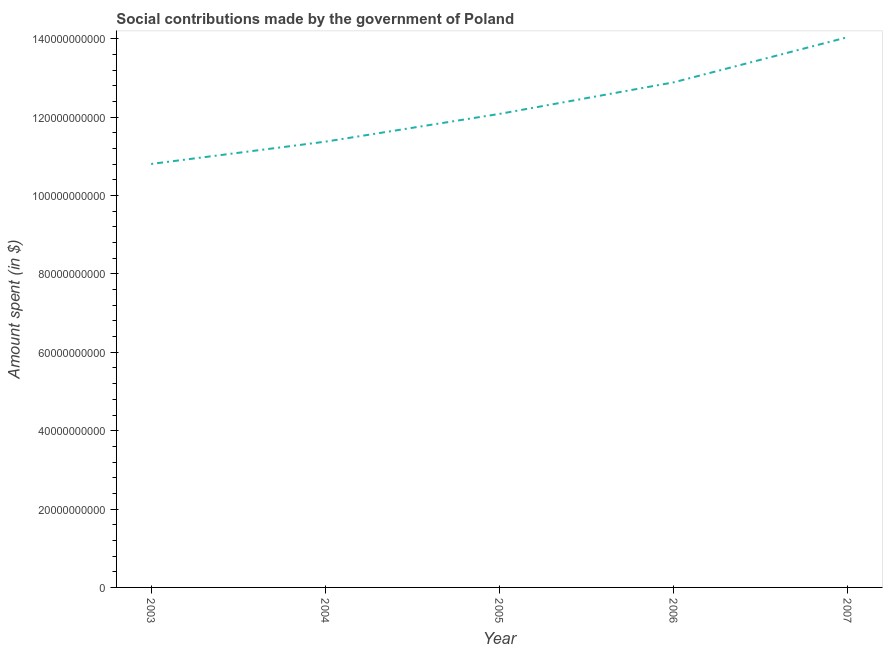What is the amount spent in making social contributions in 2003?
Your answer should be compact. 1.08e+11. Across all years, what is the maximum amount spent in making social contributions?
Give a very brief answer. 1.40e+11. Across all years, what is the minimum amount spent in making social contributions?
Offer a terse response. 1.08e+11. In which year was the amount spent in making social contributions minimum?
Ensure brevity in your answer.  2003. What is the sum of the amount spent in making social contributions?
Your response must be concise. 6.12e+11. What is the difference between the amount spent in making social contributions in 2005 and 2007?
Provide a short and direct response. -1.96e+1. What is the average amount spent in making social contributions per year?
Give a very brief answer. 1.22e+11. What is the median amount spent in making social contributions?
Provide a short and direct response. 1.21e+11. What is the ratio of the amount spent in making social contributions in 2004 to that in 2006?
Your answer should be compact. 0.88. Is the difference between the amount spent in making social contributions in 2005 and 2007 greater than the difference between any two years?
Your answer should be compact. No. What is the difference between the highest and the second highest amount spent in making social contributions?
Keep it short and to the point. 1.15e+1. Is the sum of the amount spent in making social contributions in 2005 and 2007 greater than the maximum amount spent in making social contributions across all years?
Your answer should be very brief. Yes. What is the difference between the highest and the lowest amount spent in making social contributions?
Keep it short and to the point. 3.24e+1. How many lines are there?
Provide a short and direct response. 1. How many years are there in the graph?
Your response must be concise. 5. Are the values on the major ticks of Y-axis written in scientific E-notation?
Make the answer very short. No. Does the graph contain any zero values?
Offer a terse response. No. Does the graph contain grids?
Make the answer very short. No. What is the title of the graph?
Offer a very short reply. Social contributions made by the government of Poland. What is the label or title of the Y-axis?
Make the answer very short. Amount spent (in $). What is the Amount spent (in $) in 2003?
Offer a terse response. 1.08e+11. What is the Amount spent (in $) in 2004?
Make the answer very short. 1.14e+11. What is the Amount spent (in $) of 2005?
Make the answer very short. 1.21e+11. What is the Amount spent (in $) of 2006?
Provide a succinct answer. 1.29e+11. What is the Amount spent (in $) in 2007?
Provide a succinct answer. 1.40e+11. What is the difference between the Amount spent (in $) in 2003 and 2004?
Offer a very short reply. -5.68e+09. What is the difference between the Amount spent (in $) in 2003 and 2005?
Your answer should be compact. -1.28e+1. What is the difference between the Amount spent (in $) in 2003 and 2006?
Your answer should be very brief. -2.08e+1. What is the difference between the Amount spent (in $) in 2003 and 2007?
Ensure brevity in your answer.  -3.24e+1. What is the difference between the Amount spent (in $) in 2004 and 2005?
Offer a very short reply. -7.09e+09. What is the difference between the Amount spent (in $) in 2004 and 2006?
Give a very brief answer. -1.51e+1. What is the difference between the Amount spent (in $) in 2004 and 2007?
Your response must be concise. -2.67e+1. What is the difference between the Amount spent (in $) in 2005 and 2006?
Provide a succinct answer. -8.05e+09. What is the difference between the Amount spent (in $) in 2005 and 2007?
Offer a terse response. -1.96e+1. What is the difference between the Amount spent (in $) in 2006 and 2007?
Ensure brevity in your answer.  -1.15e+1. What is the ratio of the Amount spent (in $) in 2003 to that in 2005?
Provide a succinct answer. 0.89. What is the ratio of the Amount spent (in $) in 2003 to that in 2006?
Provide a short and direct response. 0.84. What is the ratio of the Amount spent (in $) in 2003 to that in 2007?
Give a very brief answer. 0.77. What is the ratio of the Amount spent (in $) in 2004 to that in 2005?
Make the answer very short. 0.94. What is the ratio of the Amount spent (in $) in 2004 to that in 2006?
Provide a succinct answer. 0.88. What is the ratio of the Amount spent (in $) in 2004 to that in 2007?
Ensure brevity in your answer.  0.81. What is the ratio of the Amount spent (in $) in 2005 to that in 2006?
Your response must be concise. 0.94. What is the ratio of the Amount spent (in $) in 2005 to that in 2007?
Make the answer very short. 0.86. What is the ratio of the Amount spent (in $) in 2006 to that in 2007?
Your answer should be compact. 0.92. 